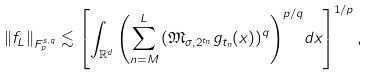Convert formula to latex. <formula><loc_0><loc_0><loc_500><loc_500>\left \| f _ { L } \right \| _ { F _ { p } ^ { { s } , q } } \lesssim \left [ \int _ { \mathbb { R } ^ { d } } { \left ( \sum _ { n = M } ^ { L } { \left ( \mathfrak { M } _ { { \sigma } , 2 ^ { t _ { n } } } { g _ { t _ { n } } } ( x ) \right ) ^ { q } } \right ) ^ { { p } / { q } } } d x \right ] ^ { { 1 } / { p } } ,</formula> 